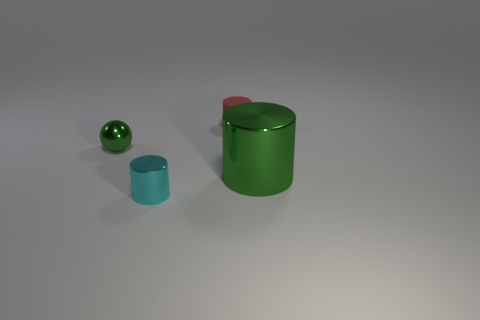Is the color of the tiny metal ball the same as the tiny metallic cylinder?
Your response must be concise. No. There is a tiny cylinder that is in front of the green metallic thing that is left of the rubber thing; what color is it?
Make the answer very short. Cyan. Is there a small metallic sphere that has the same color as the large object?
Ensure brevity in your answer.  Yes. How big is the green object that is in front of the tiny metallic thing behind the small metallic thing that is to the right of the metallic sphere?
Keep it short and to the point. Large. There is a cyan thing; is its shape the same as the metallic object behind the large green metallic thing?
Make the answer very short. No. How many other objects are the same size as the matte thing?
Keep it short and to the point. 2. There is a green thing in front of the tiny sphere; how big is it?
Your answer should be very brief. Large. What number of other green cylinders are made of the same material as the large cylinder?
Your response must be concise. 0. There is a tiny thing behind the metal sphere; is its shape the same as the small green metallic thing?
Provide a short and direct response. No. What shape is the tiny metallic object in front of the green metallic sphere?
Provide a short and direct response. Cylinder. 